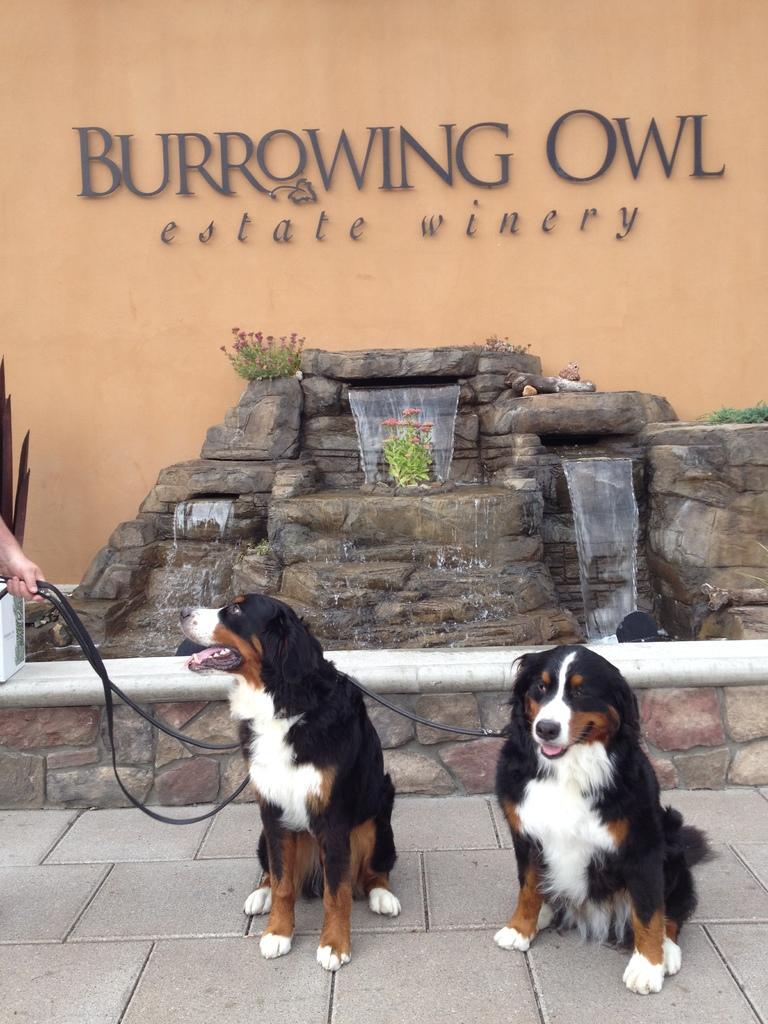How would you summarize this image in a sentence or two? In this picture I can see there are two dogs and they have belts and there is a person holding them at left and there is a wall in the backdrop and there is a name written on it. 